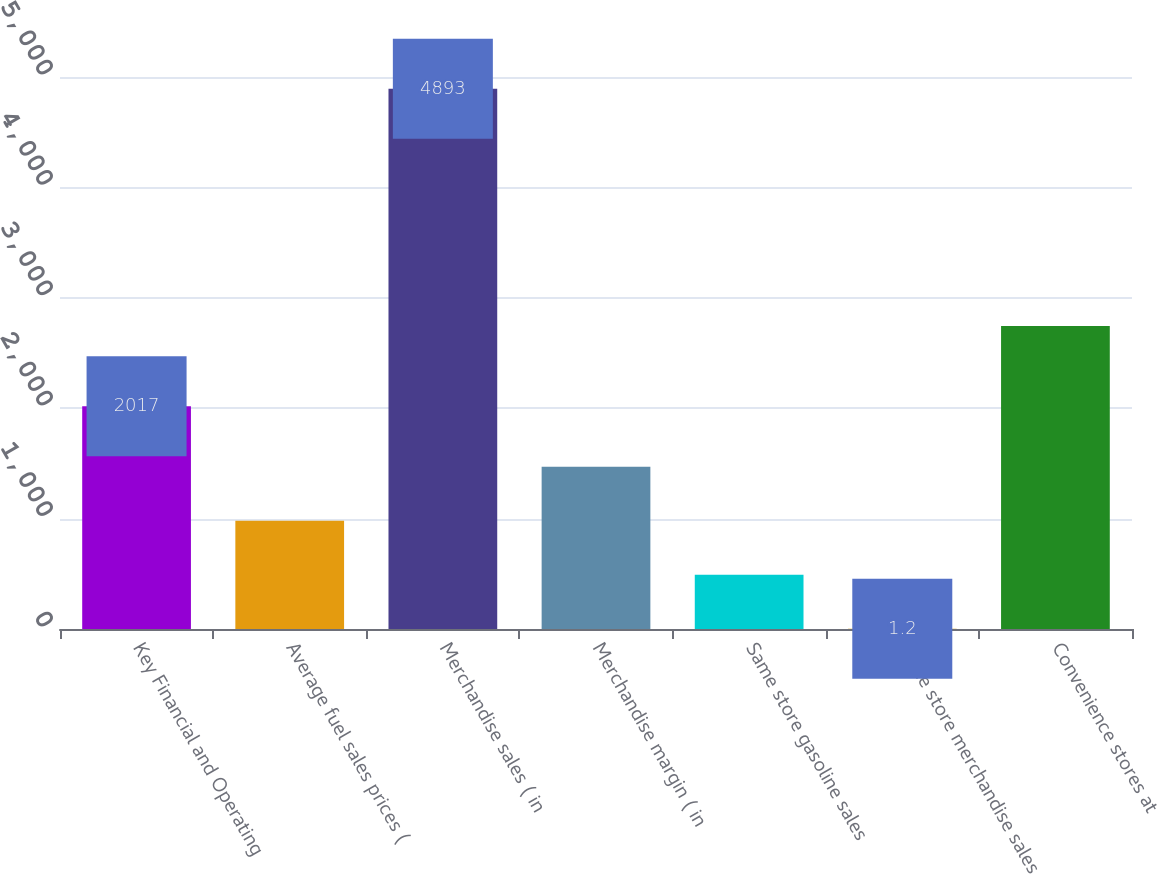Convert chart. <chart><loc_0><loc_0><loc_500><loc_500><bar_chart><fcel>Key Financial and Operating<fcel>Average fuel sales prices (<fcel>Merchandise sales ( in<fcel>Merchandise margin ( in<fcel>Same store gasoline sales<fcel>Same store merchandise sales<fcel>Convenience stores at<nl><fcel>2017<fcel>979.56<fcel>4893<fcel>1468.74<fcel>490.38<fcel>1.2<fcel>2744<nl></chart> 